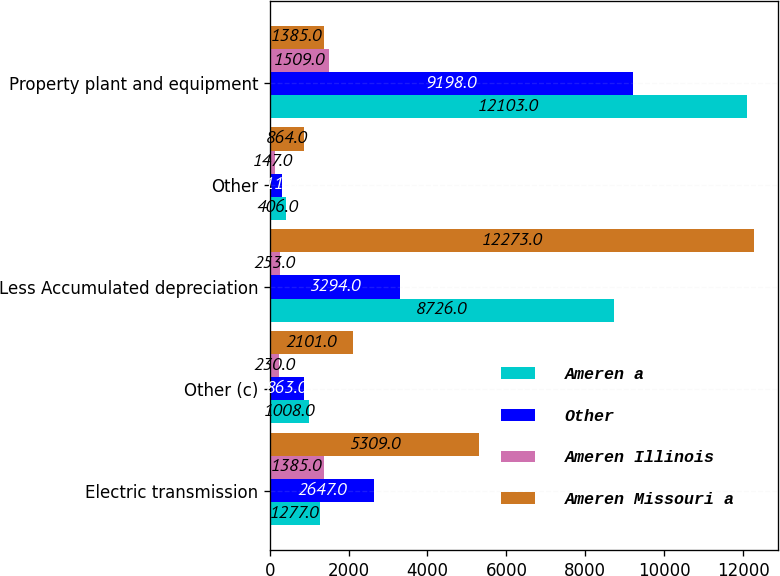<chart> <loc_0><loc_0><loc_500><loc_500><stacked_bar_chart><ecel><fcel>Electric transmission<fcel>Other (c)<fcel>Less Accumulated depreciation<fcel>Other<fcel>Property plant and equipment<nl><fcel>Ameren a<fcel>1277<fcel>1008<fcel>8726<fcel>406<fcel>12103<nl><fcel>Other<fcel>2647<fcel>863<fcel>3294<fcel>311<fcel>9198<nl><fcel>Ameren Illinois<fcel>1385<fcel>230<fcel>253<fcel>147<fcel>1509<nl><fcel>Ameren Missouri a<fcel>5309<fcel>2101<fcel>12273<fcel>864<fcel>1385<nl></chart> 